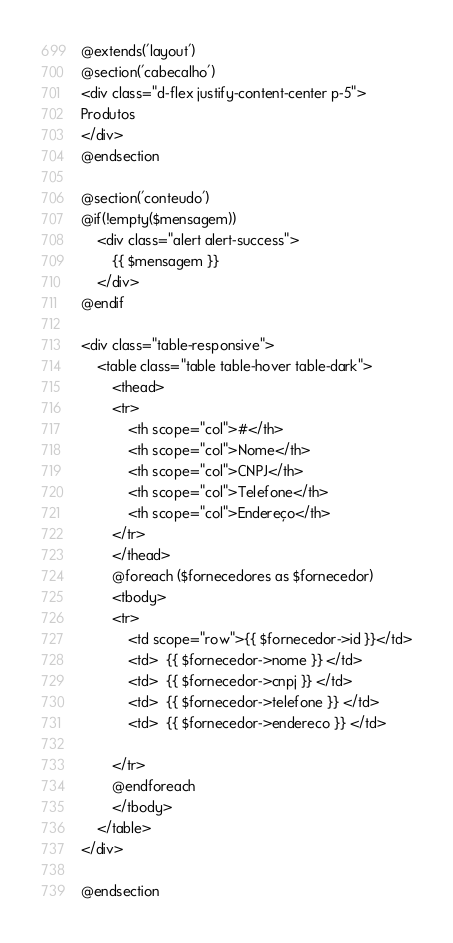Convert code to text. <code><loc_0><loc_0><loc_500><loc_500><_PHP_>@extends('layout')
@section('cabecalho')
<div class="d-flex justify-content-center p-5">
Produtos
</div>
@endsection

@section('conteudo')
@if(!empty($mensagem))
    <div class="alert alert-success">
        {{ $mensagem }}
    </div>
@endif

<div class="table-responsive">
    <table class="table table-hover table-dark">
        <thead>
        <tr>
            <th scope="col">#</th>
            <th scope="col">Nome</th>
            <th scope="col">CNPJ</th>
            <th scope="col">Telefone</th>
            <th scope="col">Endereço</th>
        </tr>
        </thead>
        @foreach ($fornecedores as $fornecedor)
        <tbody>
        <tr>
            <td scope="row">{{ $fornecedor->id }}</td>
            <td>  {{ $fornecedor->nome }} </td>
            <td>  {{ $fornecedor->cnpj }} </td>
            <td>  {{ $fornecedor->telefone }} </td>
            <td>  {{ $fornecedor->endereco }} </td>

        </tr>
        @endforeach
        </tbody>
    </table>
</div>

@endsection</code> 